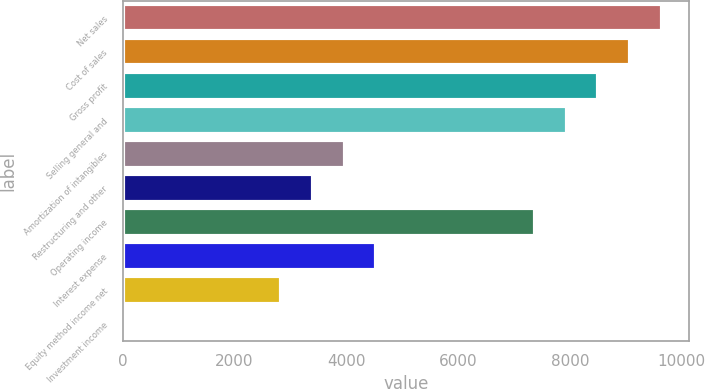Convert chart to OTSL. <chart><loc_0><loc_0><loc_500><loc_500><bar_chart><fcel>Net sales<fcel>Cost of sales<fcel>Gross profit<fcel>Selling general and<fcel>Amortization of intangibles<fcel>Restructuring and other<fcel>Operating income<fcel>Interest expense<fcel>Equity method income net<fcel>Investment income<nl><fcel>9640.68<fcel>9073.64<fcel>8506.6<fcel>7939.56<fcel>3970.28<fcel>3403.24<fcel>7372.52<fcel>4537.32<fcel>2836.2<fcel>1<nl></chart> 